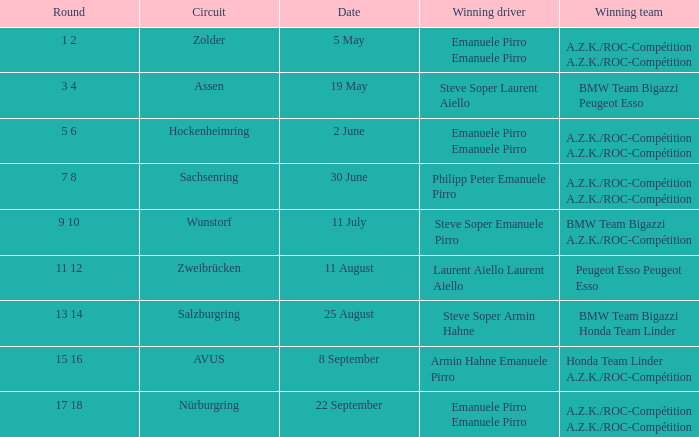What is the round on 30 June with a.z.k./roc-compétition a.z.k./roc-compétition as the winning team? 7 8. 